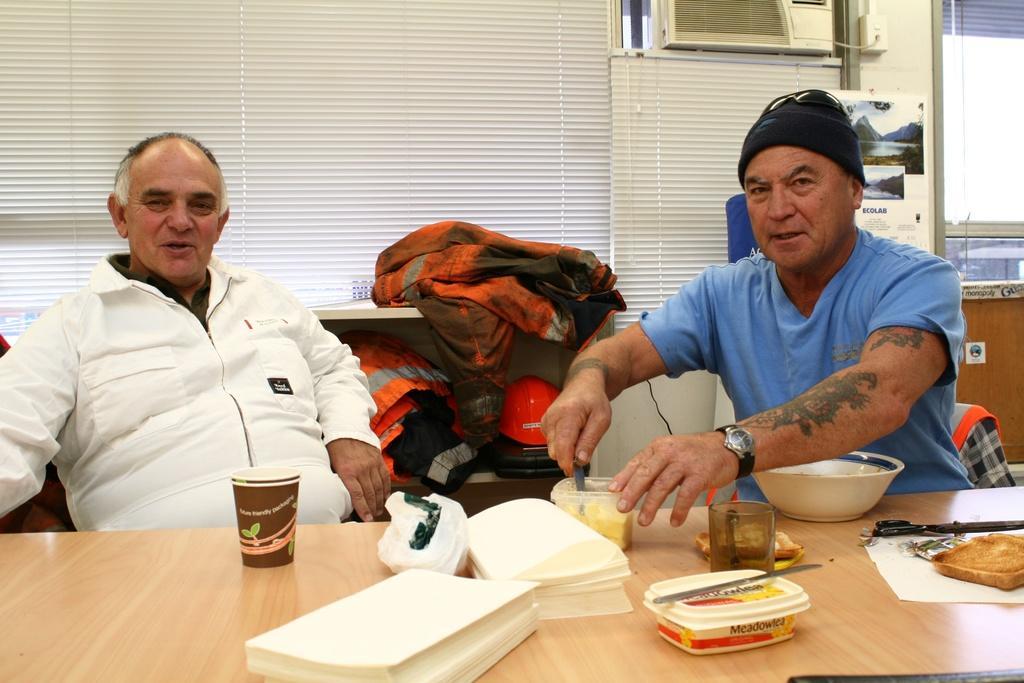How would you summarize this image in a sentence or two? In this picture we can see two person are sitting in front of a table, there are some papers, a plastic box, a bowl, two glasses, scissors, some food present on the table, in the background we can see window blinds, at the bottom there is a shelf, we can see clothes and a helmet present on the shelf, a man on the right side is holding a spoon. 